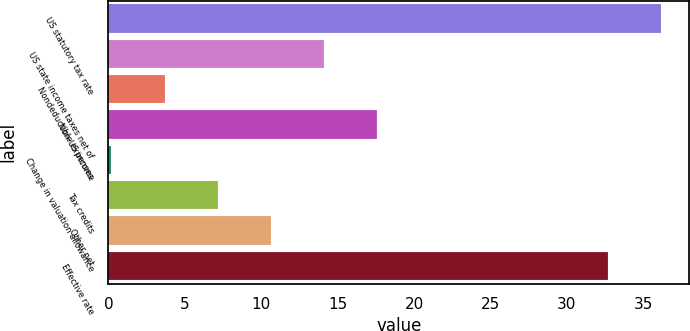<chart> <loc_0><loc_0><loc_500><loc_500><bar_chart><fcel>US statutory tax rate<fcel>US state income taxes net of<fcel>Nondeductible expenses<fcel>Non-US income<fcel>Change in valuation allowance<fcel>Tax credits<fcel>Other net<fcel>Effective rate<nl><fcel>36.18<fcel>14.12<fcel>3.68<fcel>17.6<fcel>0.2<fcel>7.16<fcel>10.64<fcel>32.7<nl></chart> 